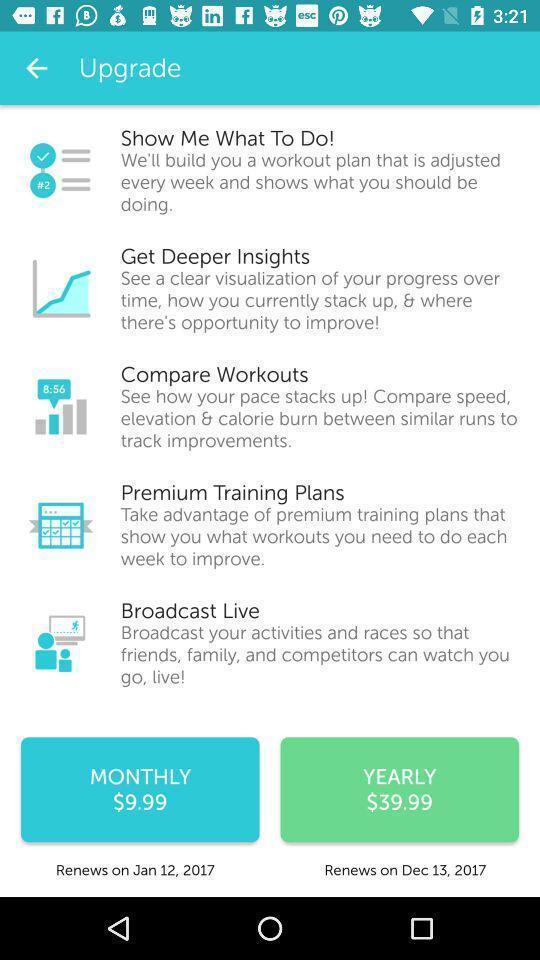Tell me about the visual elements in this screen capture. Screen showing upgrade plans in an workout application. 